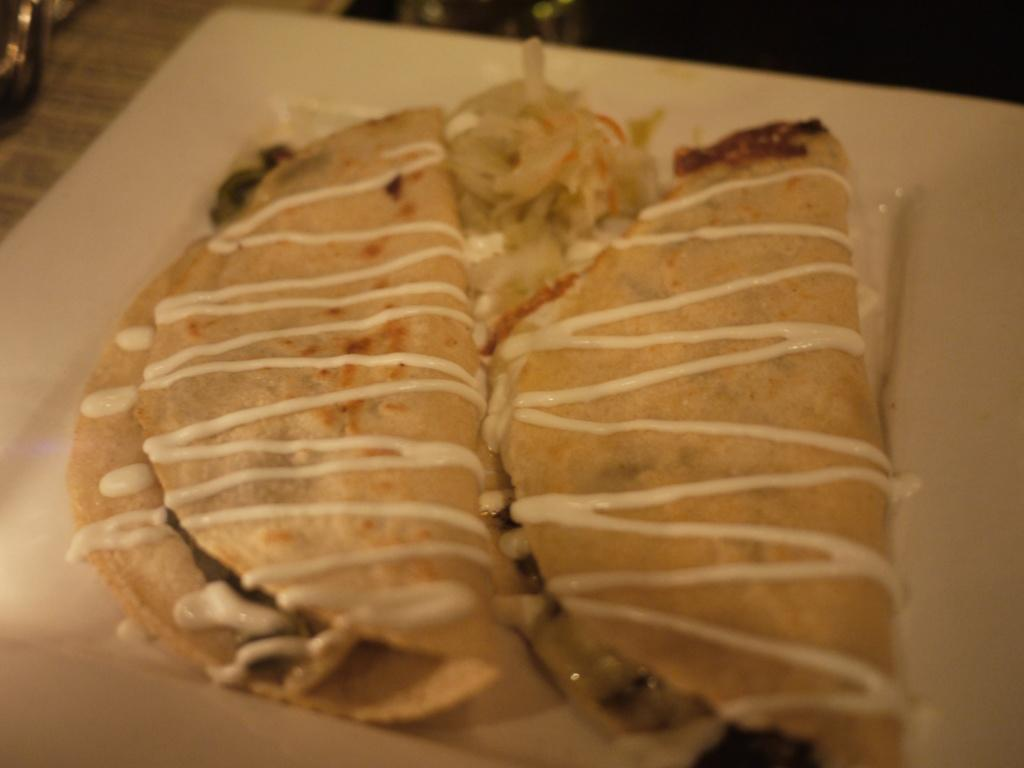What is on the plate in the image? There are food items on a plate in the image. Can you describe the background of the image? The background of the image is blurred. What type of nation is depicted on the plate in the image? There is no nation depicted on the plate in the image; it contains food items. What kind of polish is used on the plate in the image? There is no mention of polish in the image, as it focuses on the food items and the blurred background. 